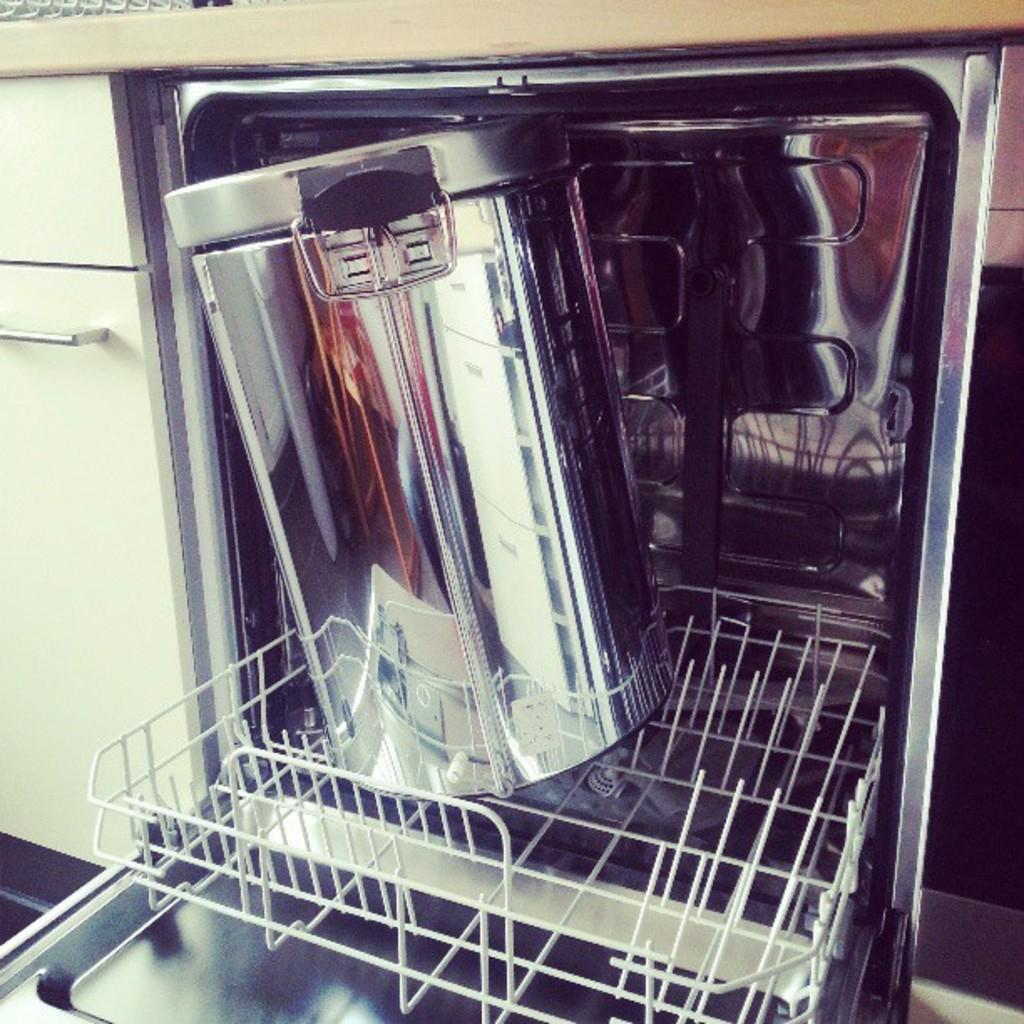What is placed inside the dishwasher in the image? There is a container placed in a dishwasher in the image. What can be seen on the left side of the image? There is a cupboard on the left side of the image. Can you see a horse grazing on the ground in the image? There is no horse or ground visible in the image; it features a container in a dishwasher and a cupboard on the left side. 